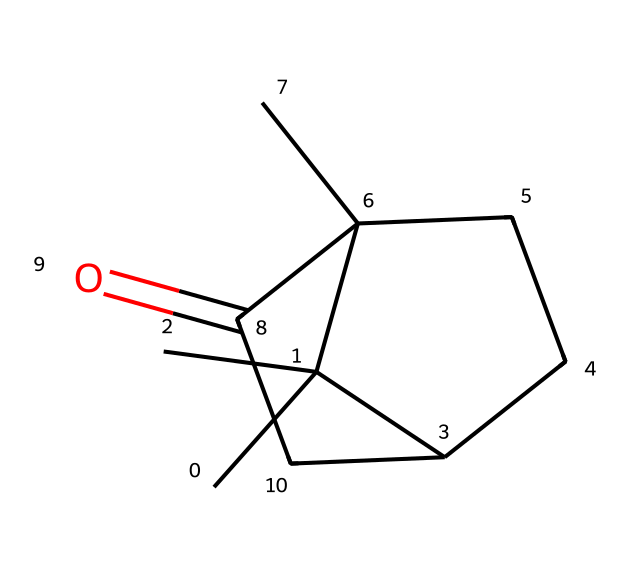What is the molecular formula of camphor? To find the molecular formula, we determine the number of carbon (C), hydrogen (H), and oxygen (O) atoms in the given SMILES representation. In the structure CC1(C)C2CCC1(C)C(=O)C2, counting the atoms leads to 10 carbons, 16 hydrogens, and 1 oxygen, resulting in the molecular formula C10H16O.
Answer: C10H16O How many rings does the molecular structure of camphor contain? The SMILES representation shows two fused rings (C1 and C2). There are two cyclopentanone rings that are connected, indicating there are two rings in the structure of camphor.
Answer: 2 Is camphor a polar or nonpolar compound? The presence of a carbonyl group (C=O) in the structure indicates that camphor has polar characteristics due to the unequal sharing of electrons. However, the majority of the structure is made up of hydrocarbons, giving it largely nonpolar traits. Thus, it is generally considered a nonpolar compound.
Answer: nonpolar How many chiral centers are present in the camphor molecular structure? A chiral center is typically defined by the presence of a carbon atom bonded to four different substituents. Examining the structure reveals two chiral centers based on the stereochemistry surrounding those carbon atoms.
Answer: 2 What type of functional group is present in camphor? The structure includes a carbonyl (C=O) functional group that is characteristic of ketones. This group is identified in the (C=O) part of the SMILES representation and is essential for classifying the chemical.
Answer: ketone What property of camphor makes it an effective insect repellent? The unique cyclic structure, combined with the volatile nature of camphor, allows it to release aromatic compounds that deter insects. The presence of the carbonyl group contributes to the strong scent, further enhancing its effectiveness as a repellent.
Answer: volatile aromatic compound 